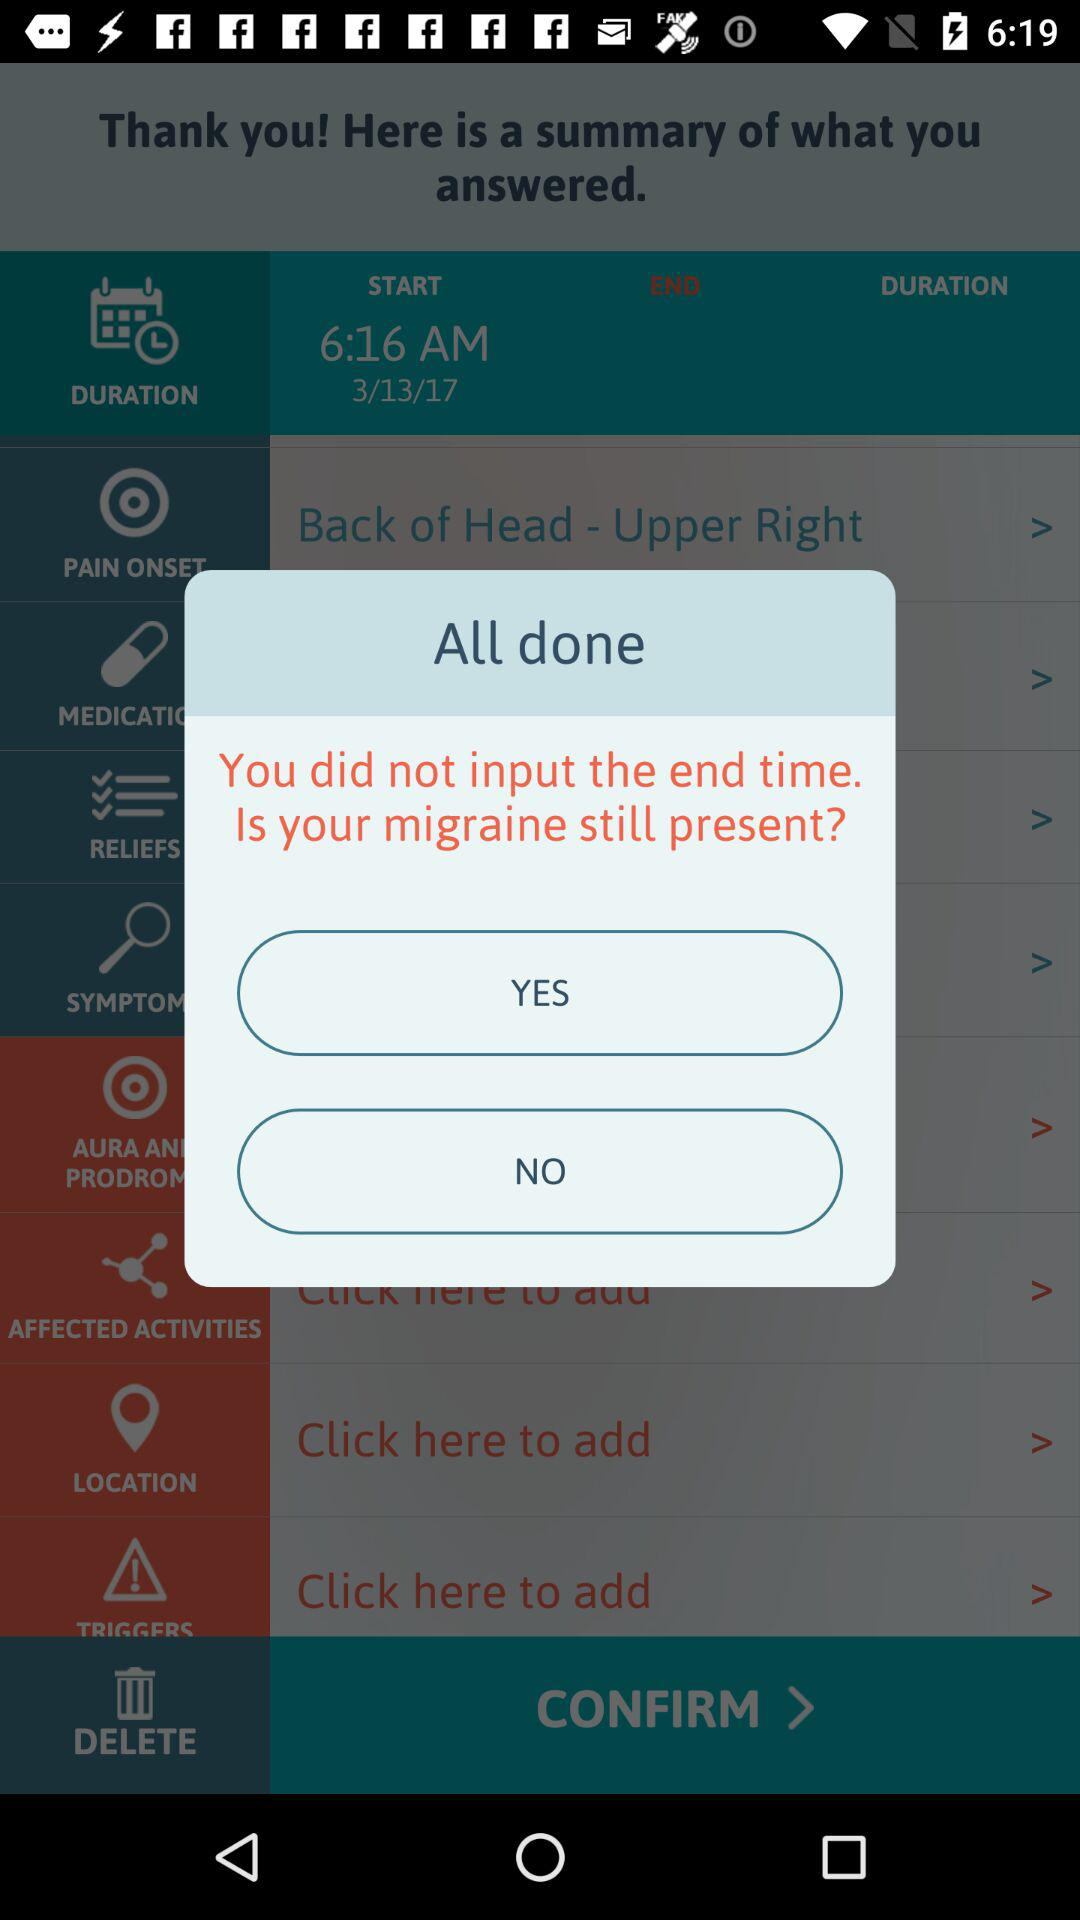What is the start time? The start time is 6:16 AM. 